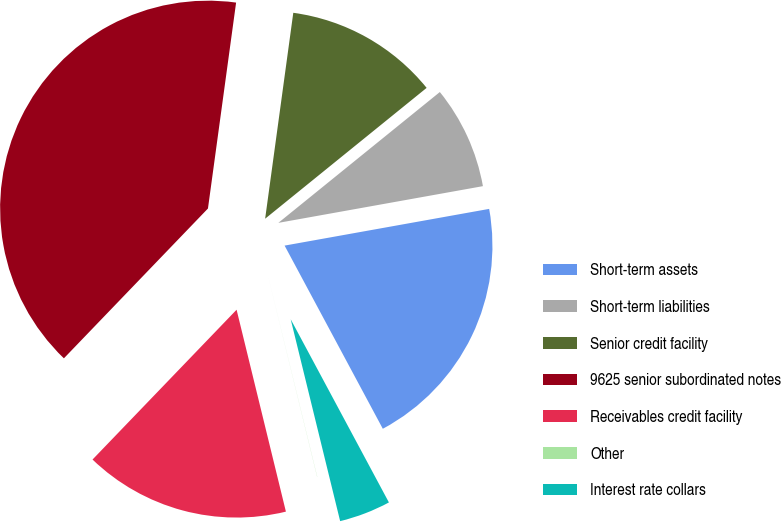<chart> <loc_0><loc_0><loc_500><loc_500><pie_chart><fcel>Short-term assets<fcel>Short-term liabilities<fcel>Senior credit facility<fcel>9625 senior subordinated notes<fcel>Receivables credit facility<fcel>Other<fcel>Interest rate collars<nl><fcel>19.99%<fcel>8.01%<fcel>12.0%<fcel>39.97%<fcel>16.0%<fcel>0.01%<fcel>4.01%<nl></chart> 